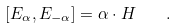Convert formula to latex. <formula><loc_0><loc_0><loc_500><loc_500>\left [ E _ { \alpha } , E _ { - \alpha } \right ] = \alpha \cdot H \quad .</formula> 